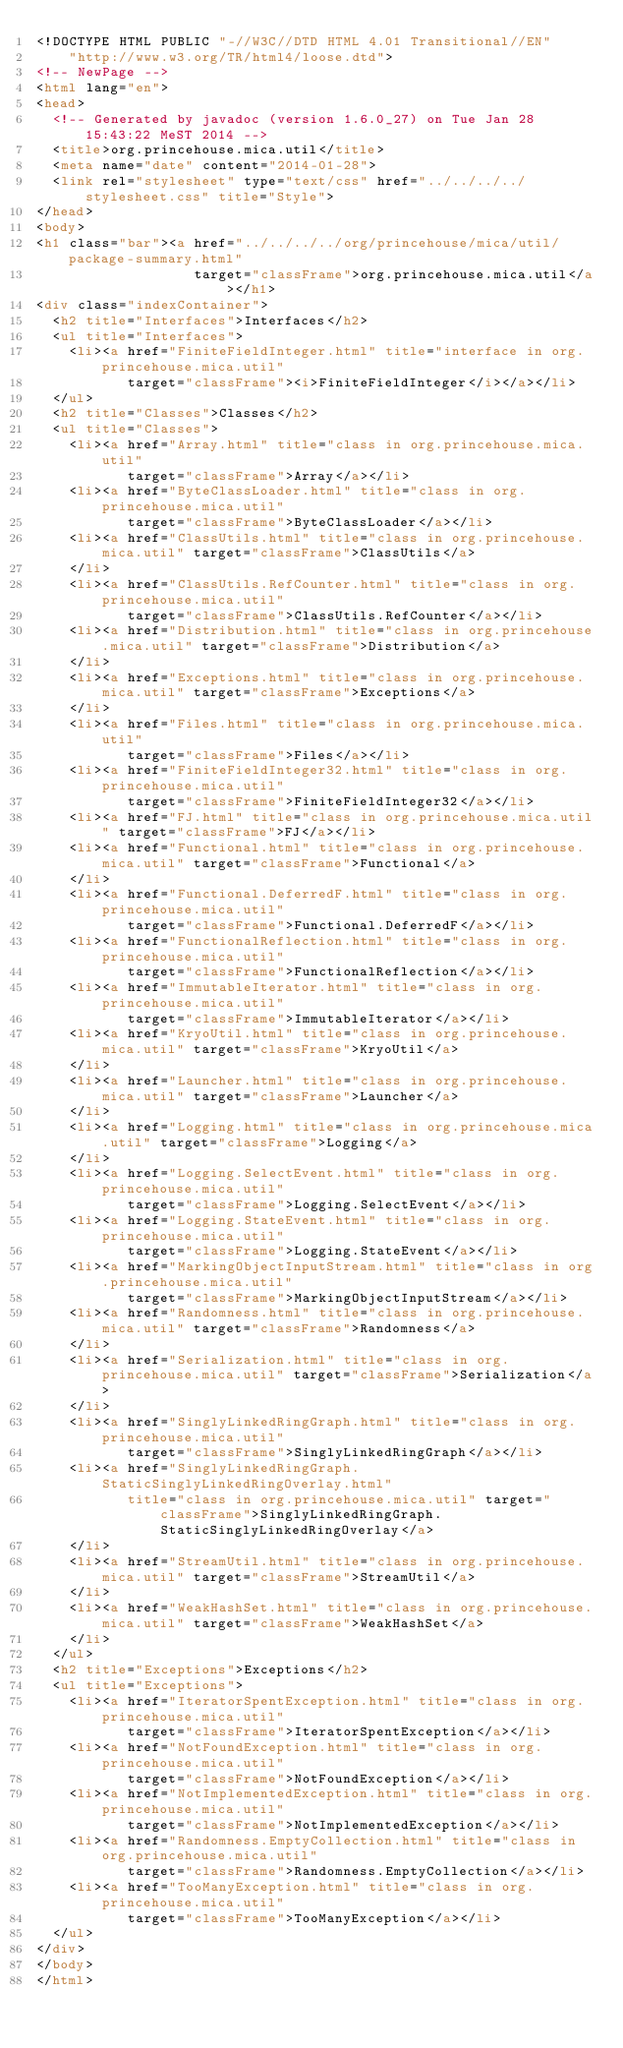<code> <loc_0><loc_0><loc_500><loc_500><_HTML_><!DOCTYPE HTML PUBLIC "-//W3C//DTD HTML 4.01 Transitional//EN"
    "http://www.w3.org/TR/html4/loose.dtd">
<!-- NewPage -->
<html lang="en">
<head>
  <!-- Generated by javadoc (version 1.6.0_27) on Tue Jan 28 15:43:22 MeST 2014 -->
  <title>org.princehouse.mica.util</title>
  <meta name="date" content="2014-01-28">
  <link rel="stylesheet" type="text/css" href="../../../../stylesheet.css" title="Style">
</head>
<body>
<h1 class="bar"><a href="../../../../org/princehouse/mica/util/package-summary.html"
                   target="classFrame">org.princehouse.mica.util</a></h1>
<div class="indexContainer">
  <h2 title="Interfaces">Interfaces</h2>
  <ul title="Interfaces">
    <li><a href="FiniteFieldInteger.html" title="interface in org.princehouse.mica.util"
           target="classFrame"><i>FiniteFieldInteger</i></a></li>
  </ul>
  <h2 title="Classes">Classes</h2>
  <ul title="Classes">
    <li><a href="Array.html" title="class in org.princehouse.mica.util"
           target="classFrame">Array</a></li>
    <li><a href="ByteClassLoader.html" title="class in org.princehouse.mica.util"
           target="classFrame">ByteClassLoader</a></li>
    <li><a href="ClassUtils.html" title="class in org.princehouse.mica.util" target="classFrame">ClassUtils</a>
    </li>
    <li><a href="ClassUtils.RefCounter.html" title="class in org.princehouse.mica.util"
           target="classFrame">ClassUtils.RefCounter</a></li>
    <li><a href="Distribution.html" title="class in org.princehouse.mica.util" target="classFrame">Distribution</a>
    </li>
    <li><a href="Exceptions.html" title="class in org.princehouse.mica.util" target="classFrame">Exceptions</a>
    </li>
    <li><a href="Files.html" title="class in org.princehouse.mica.util"
           target="classFrame">Files</a></li>
    <li><a href="FiniteFieldInteger32.html" title="class in org.princehouse.mica.util"
           target="classFrame">FiniteFieldInteger32</a></li>
    <li><a href="FJ.html" title="class in org.princehouse.mica.util" target="classFrame">FJ</a></li>
    <li><a href="Functional.html" title="class in org.princehouse.mica.util" target="classFrame">Functional</a>
    </li>
    <li><a href="Functional.DeferredF.html" title="class in org.princehouse.mica.util"
           target="classFrame">Functional.DeferredF</a></li>
    <li><a href="FunctionalReflection.html" title="class in org.princehouse.mica.util"
           target="classFrame">FunctionalReflection</a></li>
    <li><a href="ImmutableIterator.html" title="class in org.princehouse.mica.util"
           target="classFrame">ImmutableIterator</a></li>
    <li><a href="KryoUtil.html" title="class in org.princehouse.mica.util" target="classFrame">KryoUtil</a>
    </li>
    <li><a href="Launcher.html" title="class in org.princehouse.mica.util" target="classFrame">Launcher</a>
    </li>
    <li><a href="Logging.html" title="class in org.princehouse.mica.util" target="classFrame">Logging</a>
    </li>
    <li><a href="Logging.SelectEvent.html" title="class in org.princehouse.mica.util"
           target="classFrame">Logging.SelectEvent</a></li>
    <li><a href="Logging.StateEvent.html" title="class in org.princehouse.mica.util"
           target="classFrame">Logging.StateEvent</a></li>
    <li><a href="MarkingObjectInputStream.html" title="class in org.princehouse.mica.util"
           target="classFrame">MarkingObjectInputStream</a></li>
    <li><a href="Randomness.html" title="class in org.princehouse.mica.util" target="classFrame">Randomness</a>
    </li>
    <li><a href="Serialization.html" title="class in org.princehouse.mica.util" target="classFrame">Serialization</a>
    </li>
    <li><a href="SinglyLinkedRingGraph.html" title="class in org.princehouse.mica.util"
           target="classFrame">SinglyLinkedRingGraph</a></li>
    <li><a href="SinglyLinkedRingGraph.StaticSinglyLinkedRingOverlay.html"
           title="class in org.princehouse.mica.util" target="classFrame">SinglyLinkedRingGraph.StaticSinglyLinkedRingOverlay</a>
    </li>
    <li><a href="StreamUtil.html" title="class in org.princehouse.mica.util" target="classFrame">StreamUtil</a>
    </li>
    <li><a href="WeakHashSet.html" title="class in org.princehouse.mica.util" target="classFrame">WeakHashSet</a>
    </li>
  </ul>
  <h2 title="Exceptions">Exceptions</h2>
  <ul title="Exceptions">
    <li><a href="IteratorSpentException.html" title="class in org.princehouse.mica.util"
           target="classFrame">IteratorSpentException</a></li>
    <li><a href="NotFoundException.html" title="class in org.princehouse.mica.util"
           target="classFrame">NotFoundException</a></li>
    <li><a href="NotImplementedException.html" title="class in org.princehouse.mica.util"
           target="classFrame">NotImplementedException</a></li>
    <li><a href="Randomness.EmptyCollection.html" title="class in org.princehouse.mica.util"
           target="classFrame">Randomness.EmptyCollection</a></li>
    <li><a href="TooManyException.html" title="class in org.princehouse.mica.util"
           target="classFrame">TooManyException</a></li>
  </ul>
</div>
</body>
</html>
</code> 